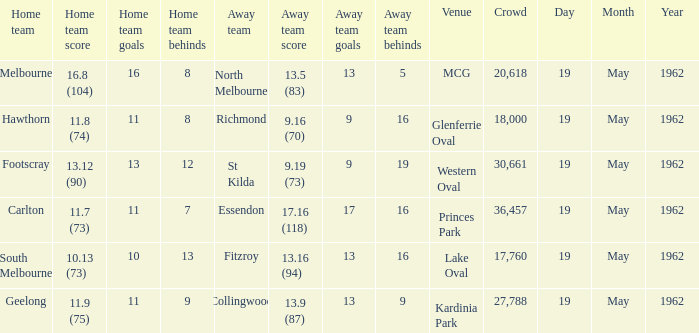What is the home team's score at mcg? 16.8 (104). 